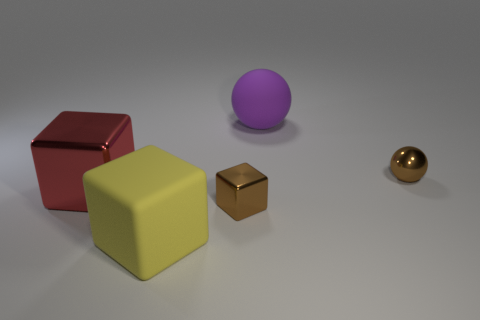Subtract all cyan balls. Subtract all gray cylinders. How many balls are left? 2 Add 5 large rubber objects. How many objects exist? 10 Subtract all spheres. How many objects are left? 3 Subtract 1 purple balls. How many objects are left? 4 Subtract all brown spheres. Subtract all brown metallic blocks. How many objects are left? 3 Add 1 purple things. How many purple things are left? 2 Add 3 blue shiny balls. How many blue shiny balls exist? 3 